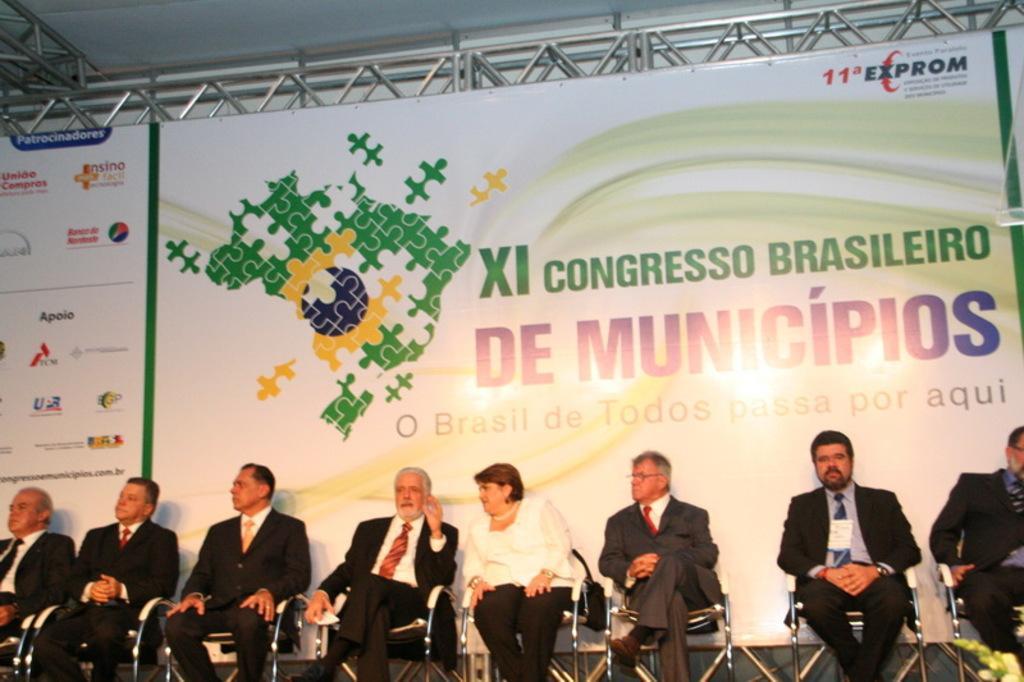Describe this image in one or two sentences. In this image I can see the group of people sitting and wearing the blazers, ties and shirts. I can see one person with the black and white color dress. In the background I can see the banner and something is written on it. 